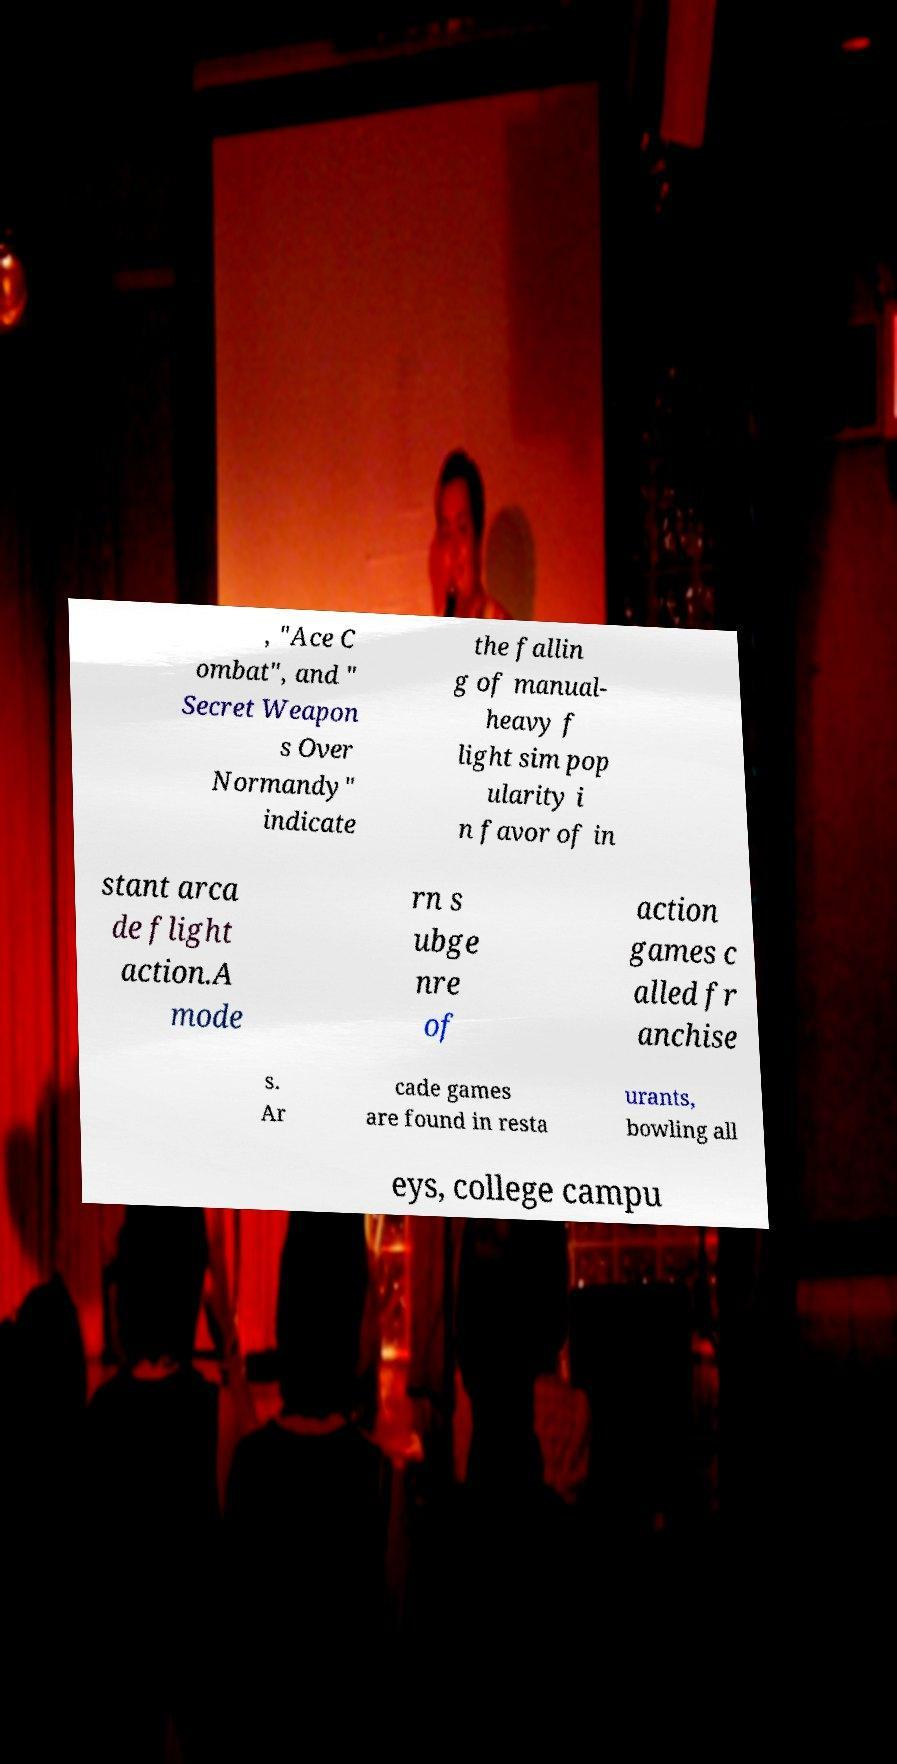For documentation purposes, I need the text within this image transcribed. Could you provide that? , "Ace C ombat", and " Secret Weapon s Over Normandy" indicate the fallin g of manual- heavy f light sim pop ularity i n favor of in stant arca de flight action.A mode rn s ubge nre of action games c alled fr anchise s. Ar cade games are found in resta urants, bowling all eys, college campu 